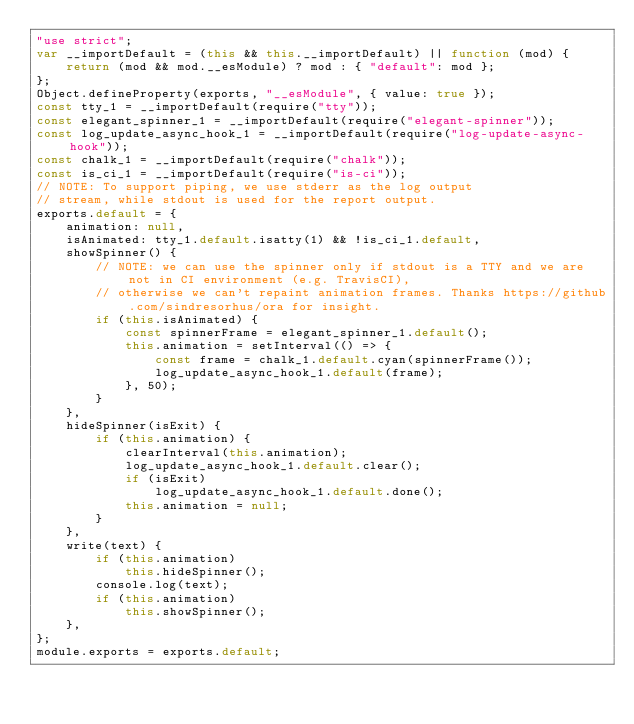<code> <loc_0><loc_0><loc_500><loc_500><_JavaScript_>"use strict";
var __importDefault = (this && this.__importDefault) || function (mod) {
    return (mod && mod.__esModule) ? mod : { "default": mod };
};
Object.defineProperty(exports, "__esModule", { value: true });
const tty_1 = __importDefault(require("tty"));
const elegant_spinner_1 = __importDefault(require("elegant-spinner"));
const log_update_async_hook_1 = __importDefault(require("log-update-async-hook"));
const chalk_1 = __importDefault(require("chalk"));
const is_ci_1 = __importDefault(require("is-ci"));
// NOTE: To support piping, we use stderr as the log output
// stream, while stdout is used for the report output.
exports.default = {
    animation: null,
    isAnimated: tty_1.default.isatty(1) && !is_ci_1.default,
    showSpinner() {
        // NOTE: we can use the spinner only if stdout is a TTY and we are not in CI environment (e.g. TravisCI),
        // otherwise we can't repaint animation frames. Thanks https://github.com/sindresorhus/ora for insight.
        if (this.isAnimated) {
            const spinnerFrame = elegant_spinner_1.default();
            this.animation = setInterval(() => {
                const frame = chalk_1.default.cyan(spinnerFrame());
                log_update_async_hook_1.default(frame);
            }, 50);
        }
    },
    hideSpinner(isExit) {
        if (this.animation) {
            clearInterval(this.animation);
            log_update_async_hook_1.default.clear();
            if (isExit)
                log_update_async_hook_1.default.done();
            this.animation = null;
        }
    },
    write(text) {
        if (this.animation)
            this.hideSpinner();
        console.log(text);
        if (this.animation)
            this.showSpinner();
    },
};
module.exports = exports.default;</code> 